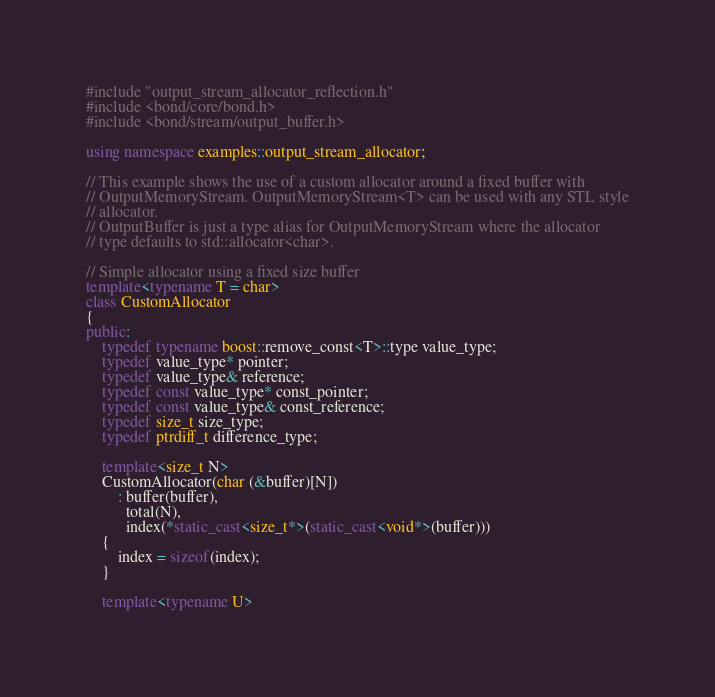Convert code to text. <code><loc_0><loc_0><loc_500><loc_500><_C++_>#include "output_stream_allocator_reflection.h"
#include <bond/core/bond.h>
#include <bond/stream/output_buffer.h>

using namespace examples::output_stream_allocator;

// This example shows the use of a custom allocator around a fixed buffer with
// OutputMemoryStream. OutputMemoryStream<T> can be used with any STL style
// allocator.
// OutputBuffer is just a type alias for OutputMemoryStream where the allocator
// type defaults to std::allocator<char>.

// Simple allocator using a fixed size buffer 
template<typename T = char>
class CustomAllocator
{
public:
    typedef typename boost::remove_const<T>::type value_type;
    typedef value_type* pointer;
    typedef value_type& reference;
    typedef const value_type* const_pointer;
    typedef const value_type& const_reference;
    typedef size_t size_type;
    typedef ptrdiff_t difference_type;

    template<size_t N> 
    CustomAllocator(char (&buffer)[N])
        : buffer(buffer), 
          total(N),
          index(*static_cast<size_t*>(static_cast<void*>(buffer)))
    {
        index = sizeof(index);
    }
    
    template<typename U></code> 